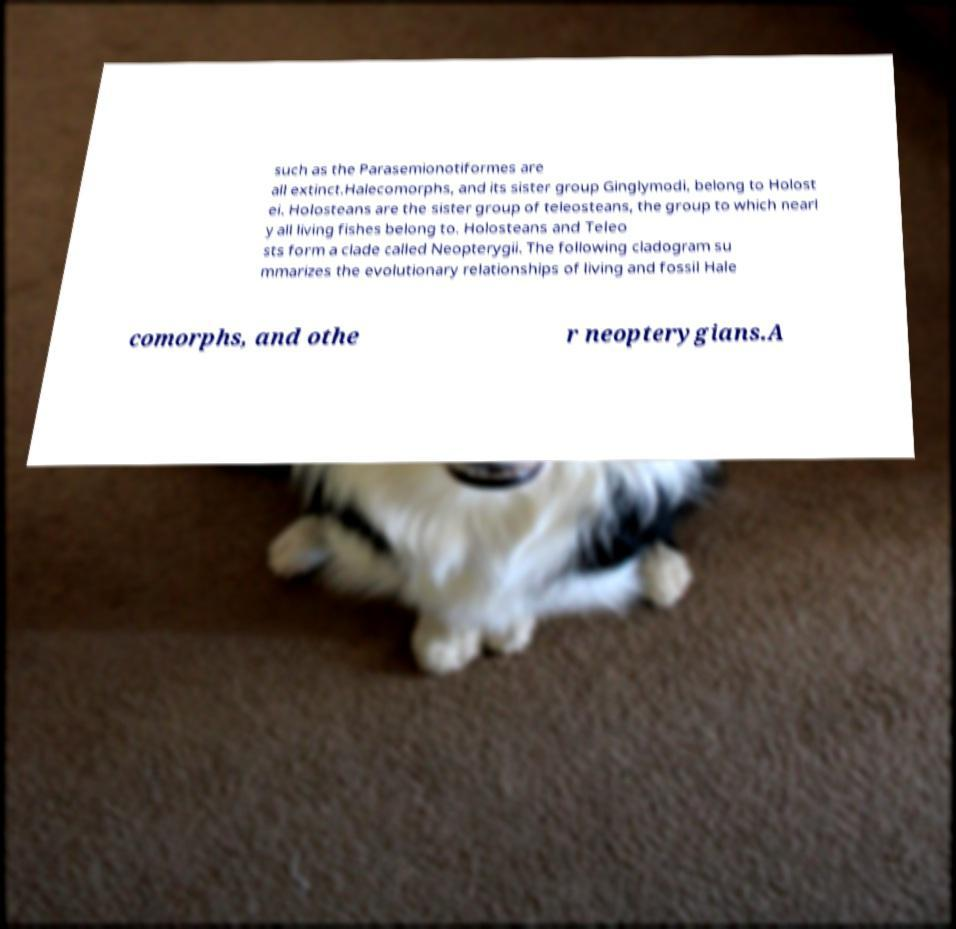Please identify and transcribe the text found in this image. such as the Parasemionotiformes are all extinct.Halecomorphs, and its sister group Ginglymodi, belong to Holost ei. Holosteans are the sister group of teleosteans, the group to which nearl y all living fishes belong to. Holosteans and Teleo sts form a clade called Neopterygii. The following cladogram su mmarizes the evolutionary relationships of living and fossil Hale comorphs, and othe r neopterygians.A 